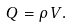<formula> <loc_0><loc_0><loc_500><loc_500>Q = \rho \, V .</formula> 